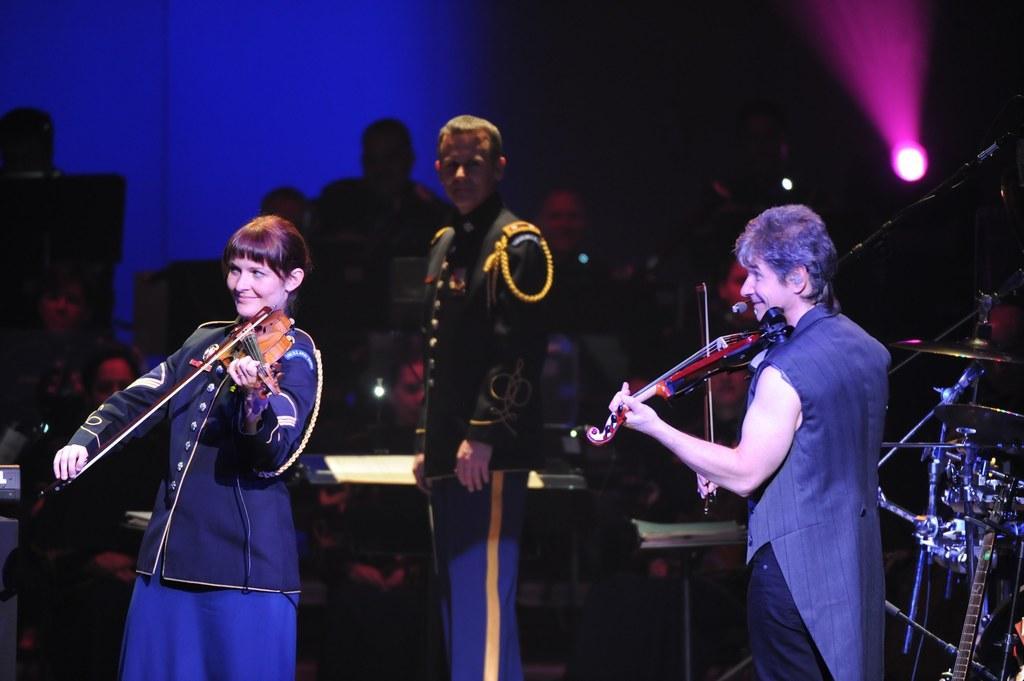Please provide a concise description of this image. In this image there are few people playing the musical instrument. 